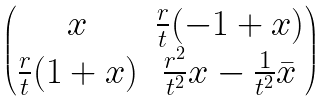<formula> <loc_0><loc_0><loc_500><loc_500>\begin{pmatrix} x & \frac { r } { t } ( - 1 + x ) \\ \frac { r } { t } ( 1 + x ) & \frac { r ^ { 2 } } { t ^ { 2 } } x - \frac { 1 } { t ^ { 2 } } \bar { x } \\ \end{pmatrix}</formula> 